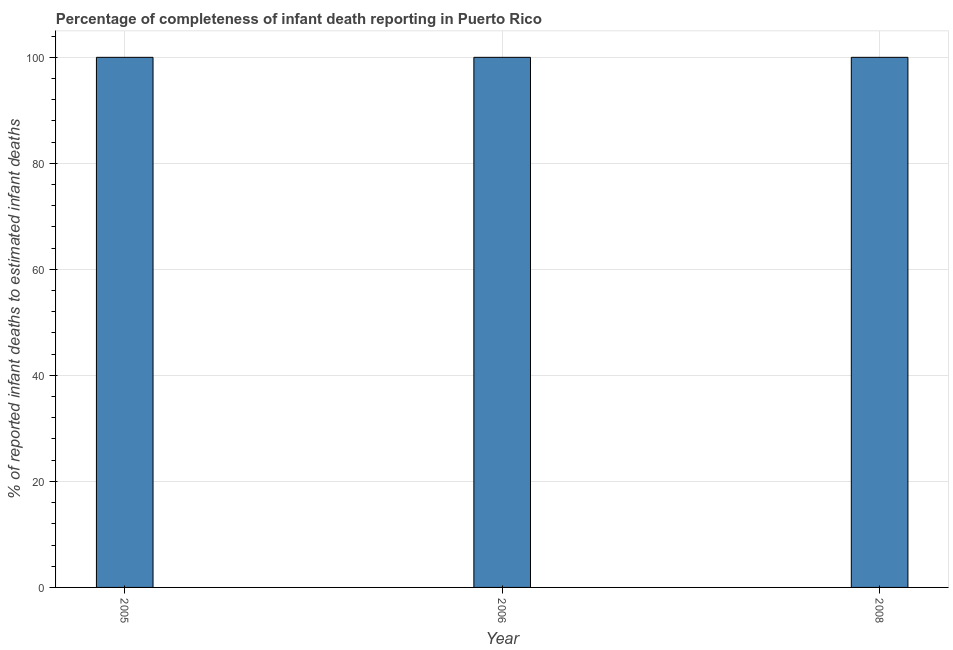What is the title of the graph?
Make the answer very short. Percentage of completeness of infant death reporting in Puerto Rico. What is the label or title of the X-axis?
Give a very brief answer. Year. What is the label or title of the Y-axis?
Your answer should be very brief. % of reported infant deaths to estimated infant deaths. Across all years, what is the maximum completeness of infant death reporting?
Provide a succinct answer. 100. Across all years, what is the minimum completeness of infant death reporting?
Ensure brevity in your answer.  100. In which year was the completeness of infant death reporting maximum?
Offer a terse response. 2005. In which year was the completeness of infant death reporting minimum?
Provide a short and direct response. 2005. What is the sum of the completeness of infant death reporting?
Provide a succinct answer. 300. Do a majority of the years between 2006 and 2005 (inclusive) have completeness of infant death reporting greater than 84 %?
Offer a very short reply. No. What is the ratio of the completeness of infant death reporting in 2006 to that in 2008?
Your response must be concise. 1. Is the completeness of infant death reporting in 2006 less than that in 2008?
Provide a short and direct response. No. Is the difference between the completeness of infant death reporting in 2005 and 2006 greater than the difference between any two years?
Your answer should be compact. Yes. What is the difference between the highest and the second highest completeness of infant death reporting?
Ensure brevity in your answer.  0. Is the sum of the completeness of infant death reporting in 2006 and 2008 greater than the maximum completeness of infant death reporting across all years?
Ensure brevity in your answer.  Yes. How many bars are there?
Offer a terse response. 3. Are all the bars in the graph horizontal?
Offer a terse response. No. What is the % of reported infant deaths to estimated infant deaths of 2008?
Give a very brief answer. 100. What is the difference between the % of reported infant deaths to estimated infant deaths in 2005 and 2008?
Your answer should be very brief. 0. 